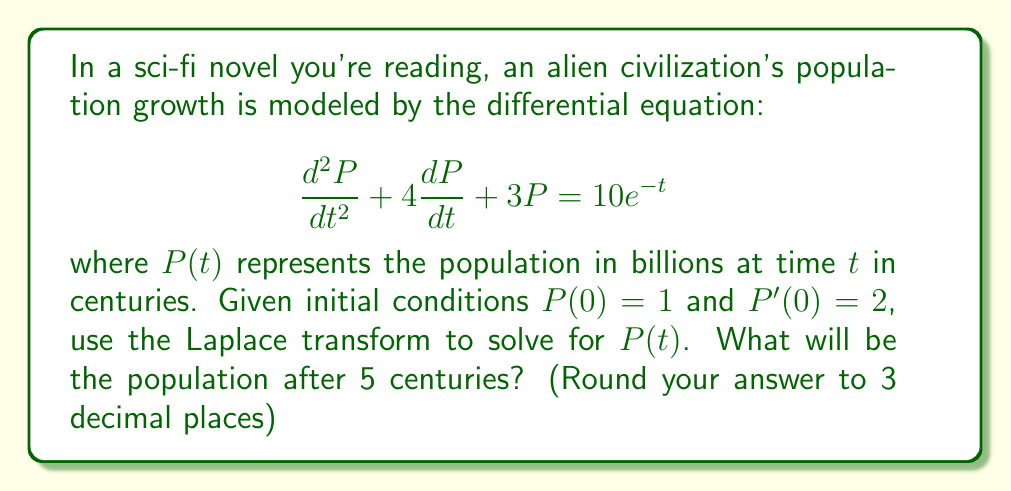Could you help me with this problem? Let's solve this step-by-step using the Laplace transform:

1) First, take the Laplace transform of both sides of the equation:
   $$\mathcal{L}\{P''(t) + 4P'(t) + 3P(t)\} = \mathcal{L}\{10e^{-t}\}$$

2) Using Laplace transform properties:
   $$s^2P(s) - sP(0) - P'(0) + 4[sP(s) - P(0)] + 3P(s) = \frac{10}{s+1}$$

3) Substitute the initial conditions $P(0) = 1$ and $P'(0) = 2$:
   $$s^2P(s) - s - 2 + 4sP(s) - 4 + 3P(s) = \frac{10}{s+1}$$

4) Simplify:
   $$(s^2 + 4s + 3)P(s) = \frac{10}{s+1} + s + 6$$

5) Solve for $P(s)$:
   $$P(s) = \frac{10}{(s+1)(s^2+4s+3)} + \frac{s+6}{s^2+4s+3}$$

6) Decompose into partial fractions:
   $$P(s) = \frac{A}{s+1} + \frac{Bs+C}{s^2+4s+3}$$

   Where $A = 1$, $B = 1$, and $C = 2$

7) Take the inverse Laplace transform:
   $$P(t) = e^{-t} + e^{-2t}(cos(t) + 2sin(t))$$

8) To find the population after 5 centuries, substitute $t = 5$:
   $$P(5) = e^{-5} + e^{-10}(cos(5) + 2sin(5))$$

9) Calculate the result:
   $$P(5) \approx 0.006738 + 0.000045(-0.958924 + 1.917849) \approx 0.007 \text{ billion}$$
Answer: After 5 centuries, the alien civilization's population will be approximately 0.007 billion (7 million). 